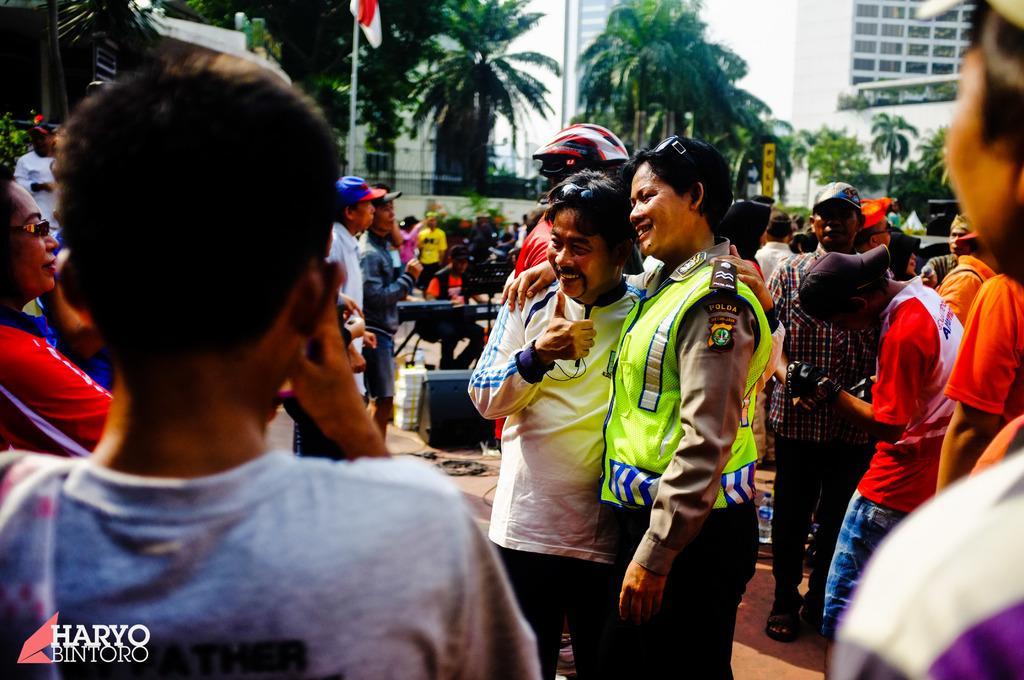Please provide a concise description of this image. In this image we can see the buildings, some objects on the ground, some people are standing, few people are walking, some people are holding objects, two poles, one flag with pole, one banner with text, some trees in the background, few objects at the top left side of the image, some plants, one water bottle, one man sitting and playing a musical instrument in the middle of the image. Two persons standing with smiling faces and holding each other. Some text with an image on the bottom left side of the image. At the top there is the sky. 